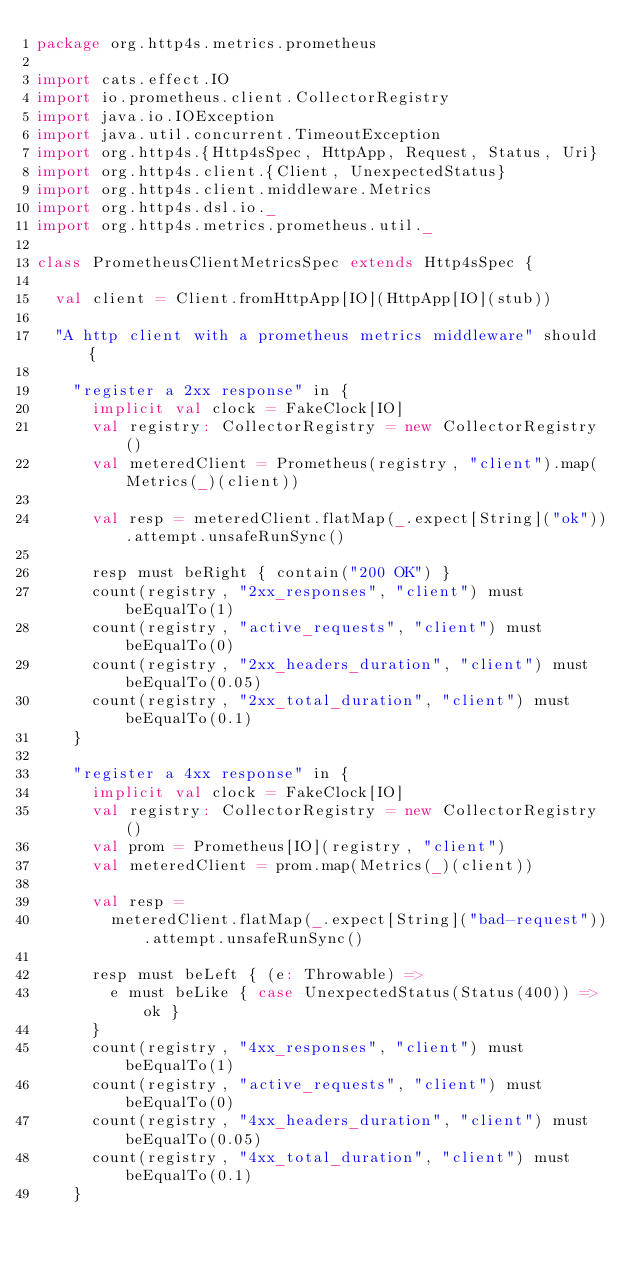<code> <loc_0><loc_0><loc_500><loc_500><_Scala_>package org.http4s.metrics.prometheus

import cats.effect.IO
import io.prometheus.client.CollectorRegistry
import java.io.IOException
import java.util.concurrent.TimeoutException
import org.http4s.{Http4sSpec, HttpApp, Request, Status, Uri}
import org.http4s.client.{Client, UnexpectedStatus}
import org.http4s.client.middleware.Metrics
import org.http4s.dsl.io._
import org.http4s.metrics.prometheus.util._

class PrometheusClientMetricsSpec extends Http4sSpec {

  val client = Client.fromHttpApp[IO](HttpApp[IO](stub))

  "A http client with a prometheus metrics middleware" should {

    "register a 2xx response" in {
      implicit val clock = FakeClock[IO]
      val registry: CollectorRegistry = new CollectorRegistry()
      val meteredClient = Prometheus(registry, "client").map(Metrics(_)(client))

      val resp = meteredClient.flatMap(_.expect[String]("ok")).attempt.unsafeRunSync()

      resp must beRight { contain("200 OK") }
      count(registry, "2xx_responses", "client") must beEqualTo(1)
      count(registry, "active_requests", "client") must beEqualTo(0)
      count(registry, "2xx_headers_duration", "client") must beEqualTo(0.05)
      count(registry, "2xx_total_duration", "client") must beEqualTo(0.1)
    }

    "register a 4xx response" in {
      implicit val clock = FakeClock[IO]
      val registry: CollectorRegistry = new CollectorRegistry()
      val prom = Prometheus[IO](registry, "client")
      val meteredClient = prom.map(Metrics(_)(client))

      val resp =
        meteredClient.flatMap(_.expect[String]("bad-request")).attempt.unsafeRunSync()

      resp must beLeft { (e: Throwable) =>
        e must beLike { case UnexpectedStatus(Status(400)) => ok }
      }
      count(registry, "4xx_responses", "client") must beEqualTo(1)
      count(registry, "active_requests", "client") must beEqualTo(0)
      count(registry, "4xx_headers_duration", "client") must beEqualTo(0.05)
      count(registry, "4xx_total_duration", "client") must beEqualTo(0.1)
    }
</code> 